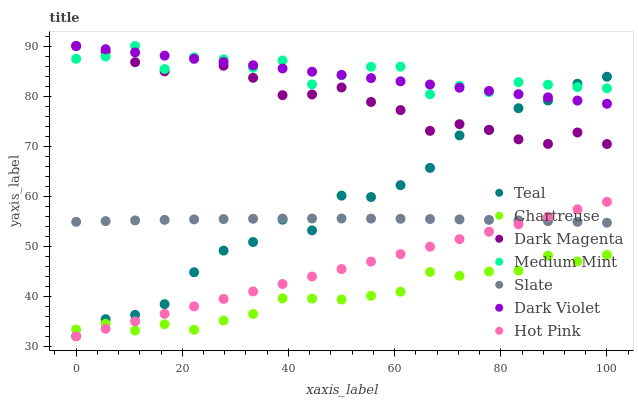Does Chartreuse have the minimum area under the curve?
Answer yes or no. Yes. Does Medium Mint have the maximum area under the curve?
Answer yes or no. Yes. Does Dark Magenta have the minimum area under the curve?
Answer yes or no. No. Does Dark Magenta have the maximum area under the curve?
Answer yes or no. No. Is Hot Pink the smoothest?
Answer yes or no. Yes. Is Teal the roughest?
Answer yes or no. Yes. Is Dark Magenta the smoothest?
Answer yes or no. No. Is Dark Magenta the roughest?
Answer yes or no. No. Does Hot Pink have the lowest value?
Answer yes or no. Yes. Does Dark Magenta have the lowest value?
Answer yes or no. No. Does Dark Violet have the highest value?
Answer yes or no. Yes. Does Slate have the highest value?
Answer yes or no. No. Is Hot Pink less than Medium Mint?
Answer yes or no. Yes. Is Medium Mint greater than Chartreuse?
Answer yes or no. Yes. Does Teal intersect Dark Magenta?
Answer yes or no. Yes. Is Teal less than Dark Magenta?
Answer yes or no. No. Is Teal greater than Dark Magenta?
Answer yes or no. No. Does Hot Pink intersect Medium Mint?
Answer yes or no. No. 